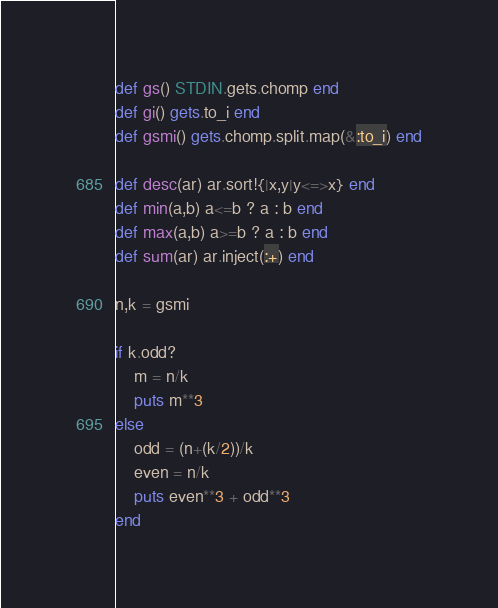<code> <loc_0><loc_0><loc_500><loc_500><_Ruby_>def gs() STDIN.gets.chomp end
def gi() gets.to_i end
def gsmi() gets.chomp.split.map(&:to_i) end
 
def desc(ar) ar.sort!{|x,y|y<=>x} end
def min(a,b) a<=b ? a : b end
def max(a,b) a>=b ? a : b end
def sum(ar) ar.inject(:+) end

n,k = gsmi

if k.odd?
	m = n/k
	puts m**3
else
	odd = (n+(k/2))/k
	even = n/k
	puts even**3 + odd**3
end</code> 